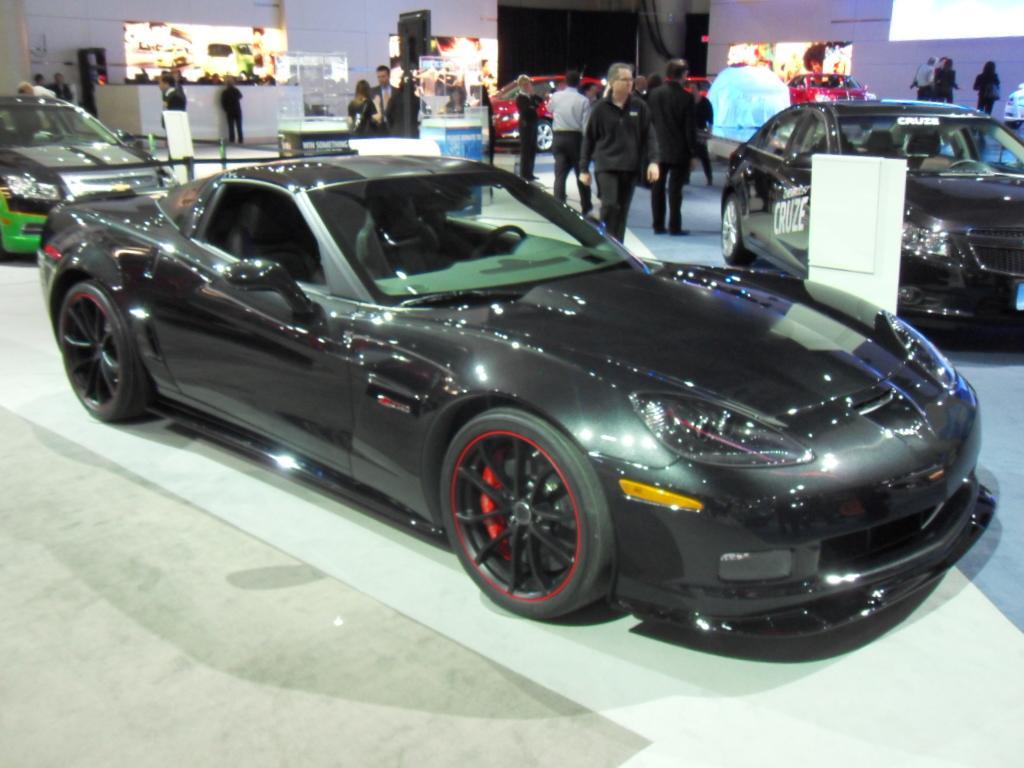Please provide a concise description of this image. In the middle of the image on the floor there is a black car. Behind the car there is another car which is in black and green color. And to the right side of the image there is a car. Behind the cars there are few people standing. Behind them there are few red cars. And in the background there are many screens to the wall. 